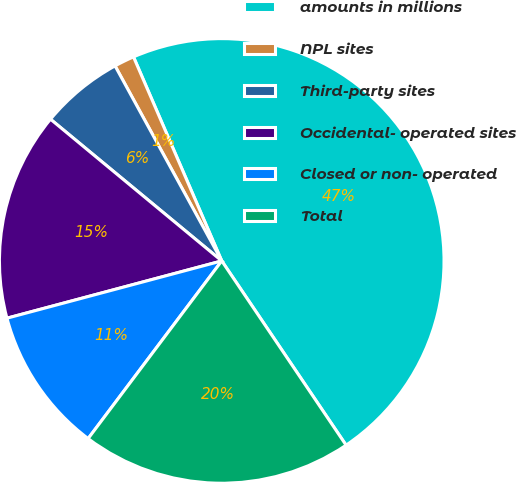<chart> <loc_0><loc_0><loc_500><loc_500><pie_chart><fcel>amounts in millions<fcel>NPL sites<fcel>Third-party sites<fcel>Occidental- operated sites<fcel>Closed or non- operated<fcel>Total<nl><fcel>47.05%<fcel>1.47%<fcel>6.03%<fcel>15.15%<fcel>10.59%<fcel>19.71%<nl></chart> 